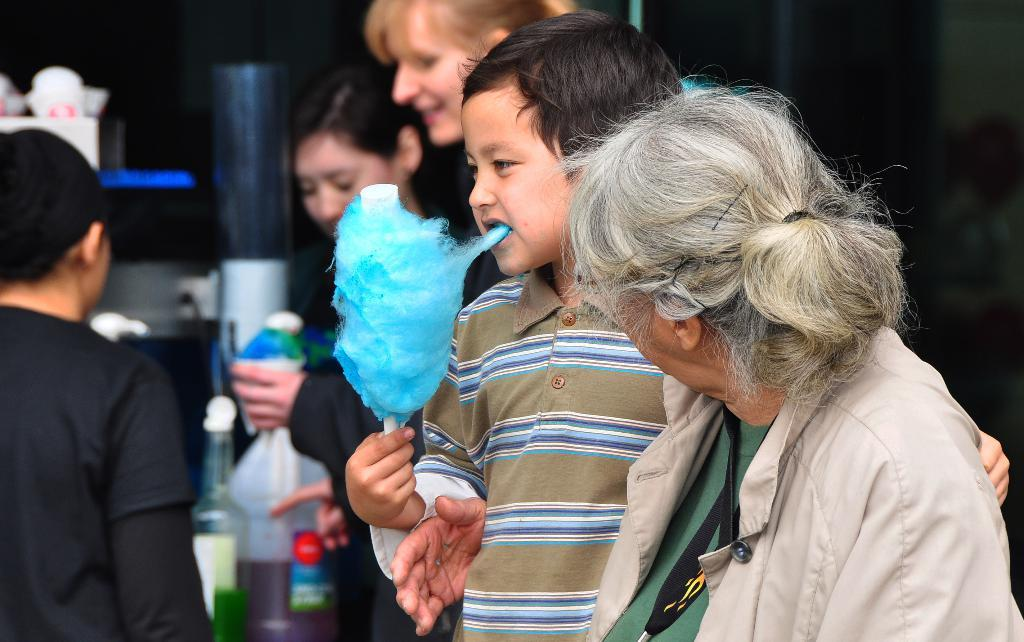Who is present in the image? There are people in the image, including a kid. What is the kid doing in the image? The kid is eating food. What type of container can be seen in the image? There is a bottle and a can in the image. Where is the owl's nest located in the image? There is no owl or nest present in the image. What type of metal is the zinc can made of in the image? There is no mention of the material of the can in the image, and there is no indication that it is made of zinc. 